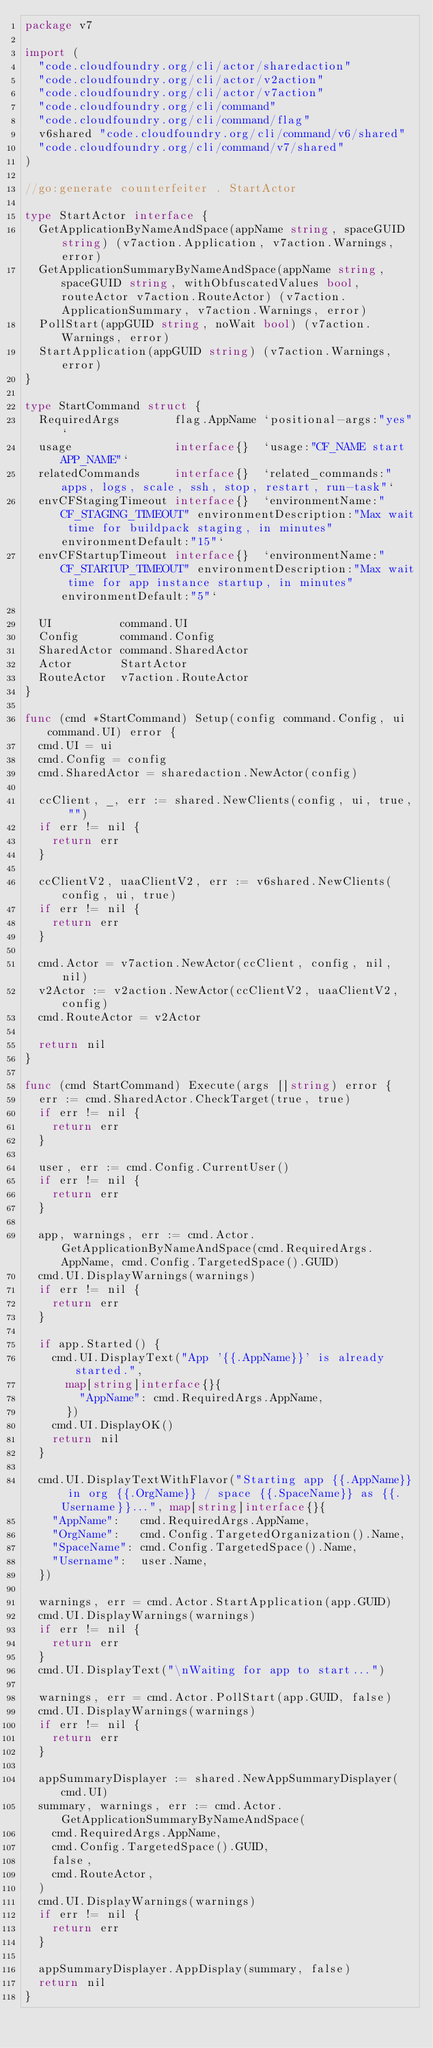<code> <loc_0><loc_0><loc_500><loc_500><_Go_>package v7

import (
	"code.cloudfoundry.org/cli/actor/sharedaction"
	"code.cloudfoundry.org/cli/actor/v2action"
	"code.cloudfoundry.org/cli/actor/v7action"
	"code.cloudfoundry.org/cli/command"
	"code.cloudfoundry.org/cli/command/flag"
	v6shared "code.cloudfoundry.org/cli/command/v6/shared"
	"code.cloudfoundry.org/cli/command/v7/shared"
)

//go:generate counterfeiter . StartActor

type StartActor interface {
	GetApplicationByNameAndSpace(appName string, spaceGUID string) (v7action.Application, v7action.Warnings, error)
	GetApplicationSummaryByNameAndSpace(appName string, spaceGUID string, withObfuscatedValues bool, routeActor v7action.RouteActor) (v7action.ApplicationSummary, v7action.Warnings, error)
	PollStart(appGUID string, noWait bool) (v7action.Warnings, error)
	StartApplication(appGUID string) (v7action.Warnings, error)
}

type StartCommand struct {
	RequiredArgs        flag.AppName `positional-args:"yes"`
	usage               interface{}  `usage:"CF_NAME start APP_NAME"`
	relatedCommands     interface{}  `related_commands:"apps, logs, scale, ssh, stop, restart, run-task"`
	envCFStagingTimeout interface{}  `environmentName:"CF_STAGING_TIMEOUT" environmentDescription:"Max wait time for buildpack staging, in minutes" environmentDefault:"15"`
	envCFStartupTimeout interface{}  `environmentName:"CF_STARTUP_TIMEOUT" environmentDescription:"Max wait time for app instance startup, in minutes" environmentDefault:"5"`

	UI          command.UI
	Config      command.Config
	SharedActor command.SharedActor
	Actor       StartActor
	RouteActor  v7action.RouteActor
}

func (cmd *StartCommand) Setup(config command.Config, ui command.UI) error {
	cmd.UI = ui
	cmd.Config = config
	cmd.SharedActor = sharedaction.NewActor(config)

	ccClient, _, err := shared.NewClients(config, ui, true, "")
	if err != nil {
		return err
	}

	ccClientV2, uaaClientV2, err := v6shared.NewClients(config, ui, true)
	if err != nil {
		return err
	}

	cmd.Actor = v7action.NewActor(ccClient, config, nil, nil)
	v2Actor := v2action.NewActor(ccClientV2, uaaClientV2, config)
	cmd.RouteActor = v2Actor

	return nil
}

func (cmd StartCommand) Execute(args []string) error {
	err := cmd.SharedActor.CheckTarget(true, true)
	if err != nil {
		return err
	}

	user, err := cmd.Config.CurrentUser()
	if err != nil {
		return err
	}

	app, warnings, err := cmd.Actor.GetApplicationByNameAndSpace(cmd.RequiredArgs.AppName, cmd.Config.TargetedSpace().GUID)
	cmd.UI.DisplayWarnings(warnings)
	if err != nil {
		return err
	}

	if app.Started() {
		cmd.UI.DisplayText("App '{{.AppName}}' is already started.",
			map[string]interface{}{
				"AppName": cmd.RequiredArgs.AppName,
			})
		cmd.UI.DisplayOK()
		return nil
	}

	cmd.UI.DisplayTextWithFlavor("Starting app {{.AppName}} in org {{.OrgName}} / space {{.SpaceName}} as {{.Username}}...", map[string]interface{}{
		"AppName":   cmd.RequiredArgs.AppName,
		"OrgName":   cmd.Config.TargetedOrganization().Name,
		"SpaceName": cmd.Config.TargetedSpace().Name,
		"Username":  user.Name,
	})

	warnings, err = cmd.Actor.StartApplication(app.GUID)
	cmd.UI.DisplayWarnings(warnings)
	if err != nil {
		return err
	}
	cmd.UI.DisplayText("\nWaiting for app to start...")

	warnings, err = cmd.Actor.PollStart(app.GUID, false)
	cmd.UI.DisplayWarnings(warnings)
	if err != nil {
		return err
	}

	appSummaryDisplayer := shared.NewAppSummaryDisplayer(cmd.UI)
	summary, warnings, err := cmd.Actor.GetApplicationSummaryByNameAndSpace(
		cmd.RequiredArgs.AppName,
		cmd.Config.TargetedSpace().GUID,
		false,
		cmd.RouteActor,
	)
	cmd.UI.DisplayWarnings(warnings)
	if err != nil {
		return err
	}

	appSummaryDisplayer.AppDisplay(summary, false)
	return nil
}
</code> 